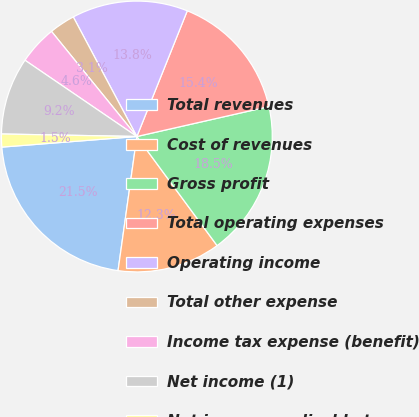<chart> <loc_0><loc_0><loc_500><loc_500><pie_chart><fcel>Total revenues<fcel>Cost of revenues<fcel>Gross profit<fcel>Total operating expenses<fcel>Operating income<fcel>Total other expense<fcel>Income tax expense (benefit)<fcel>Net income (1)<fcel>Net income applicable to<nl><fcel>21.54%<fcel>12.31%<fcel>18.46%<fcel>15.38%<fcel>13.85%<fcel>3.08%<fcel>4.62%<fcel>9.23%<fcel>1.54%<nl></chart> 